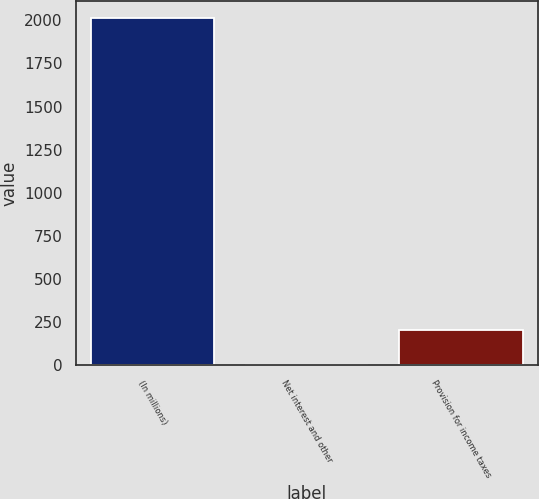Convert chart to OTSL. <chart><loc_0><loc_0><loc_500><loc_500><bar_chart><fcel>(In millions)<fcel>Net interest and other<fcel>Provision for income taxes<nl><fcel>2012<fcel>4<fcel>204.8<nl></chart> 